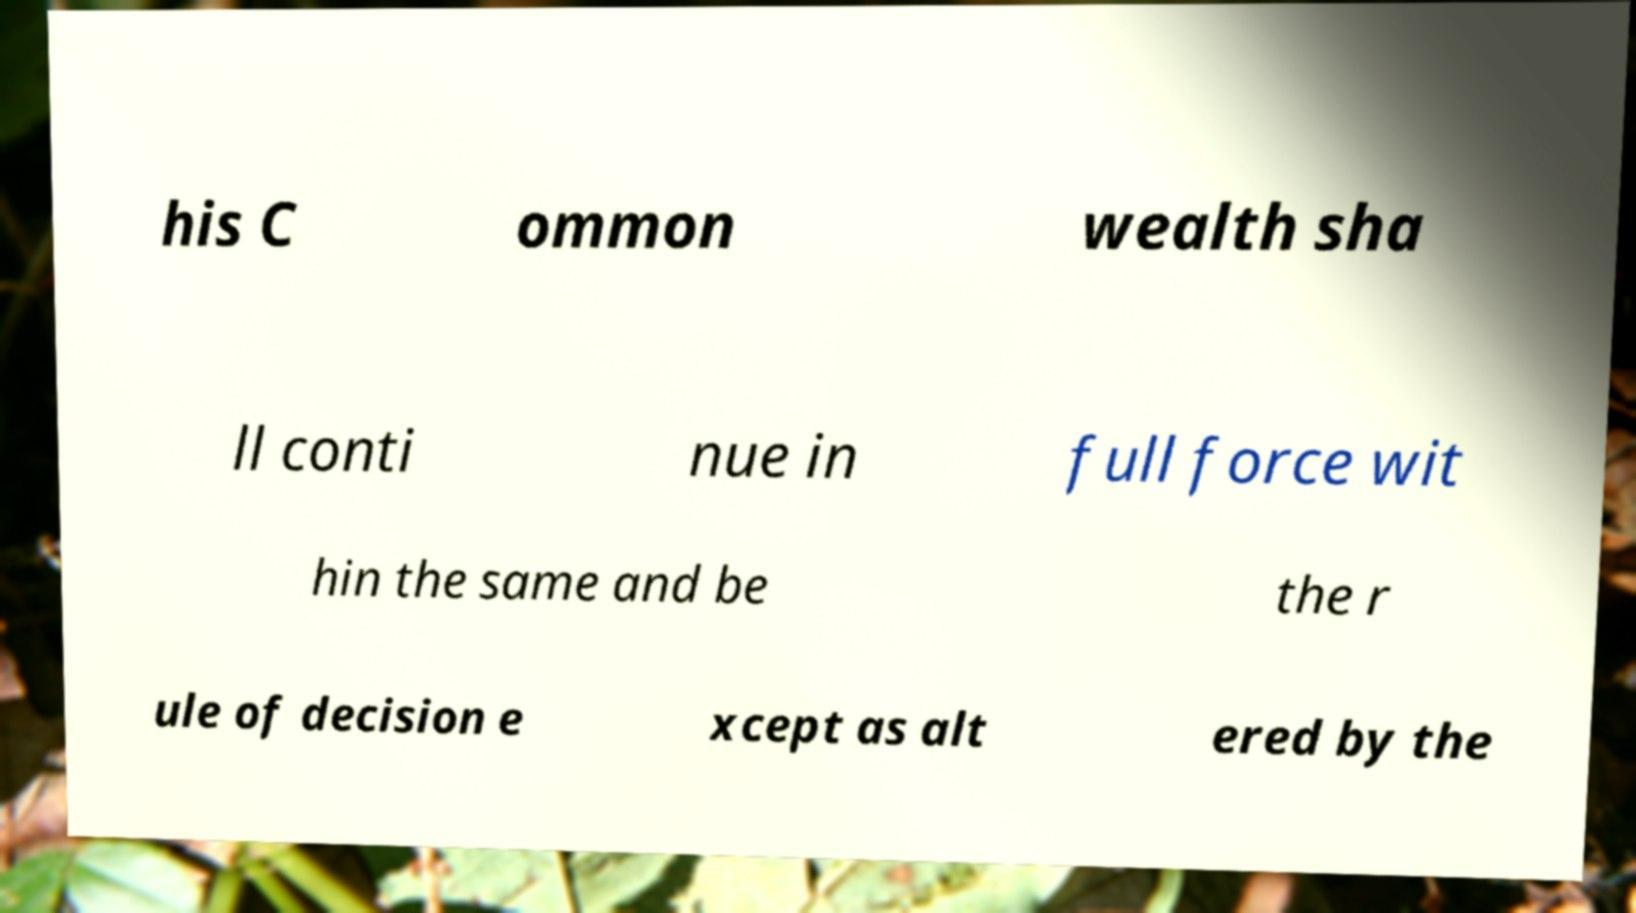Please identify and transcribe the text found in this image. his C ommon wealth sha ll conti nue in full force wit hin the same and be the r ule of decision e xcept as alt ered by the 